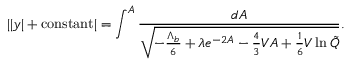<formula> <loc_0><loc_0><loc_500><loc_500>| | y | + c o n s t a n t | = \int ^ { A } \frac { d A } { \sqrt { - \frac { \Lambda _ { b } } { 6 } + \lambda e ^ { - 2 A } - \frac { 4 } { 3 } V A + \frac { 1 } { 6 } V \ln \tilde { Q } } } .</formula> 